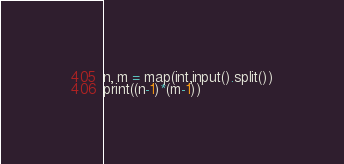<code> <loc_0><loc_0><loc_500><loc_500><_Python_>n, m = map(int,input().split())
print((n-1)*(m-1))
</code> 